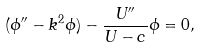Convert formula to latex. <formula><loc_0><loc_0><loc_500><loc_500>( \phi ^ { \prime \prime } - k ^ { 2 } \phi ) - \frac { U ^ { \prime \prime } } { U - c } \phi = 0 ,</formula> 